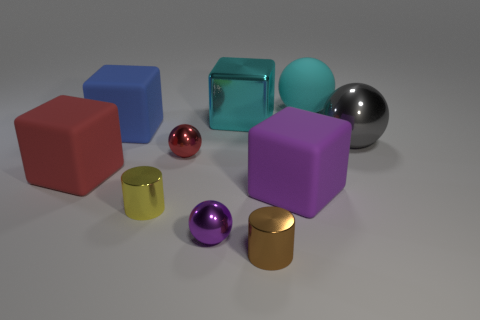Are the tiny brown object and the large red block made of the same material?
Your answer should be compact. No. How many matte objects are either big cyan cubes or purple balls?
Provide a short and direct response. 0. What is the color of the other cylinder that is the same size as the brown shiny cylinder?
Provide a short and direct response. Yellow. What number of other metal things have the same shape as the small purple metal thing?
Provide a succinct answer. 2. How many balls are brown metallic things or tiny purple metallic objects?
Your response must be concise. 1. Is the shape of the cyan matte thing that is behind the gray object the same as the red object that is on the left side of the blue thing?
Make the answer very short. No. What material is the small brown cylinder?
Your response must be concise. Metal. What shape is the large thing that is the same color as the large shiny cube?
Offer a very short reply. Sphere. What number of other metallic balls have the same size as the gray shiny sphere?
Keep it short and to the point. 0. How many things are large cubes in front of the big cyan metal object or purple spheres in front of the large red matte thing?
Provide a succinct answer. 4. 